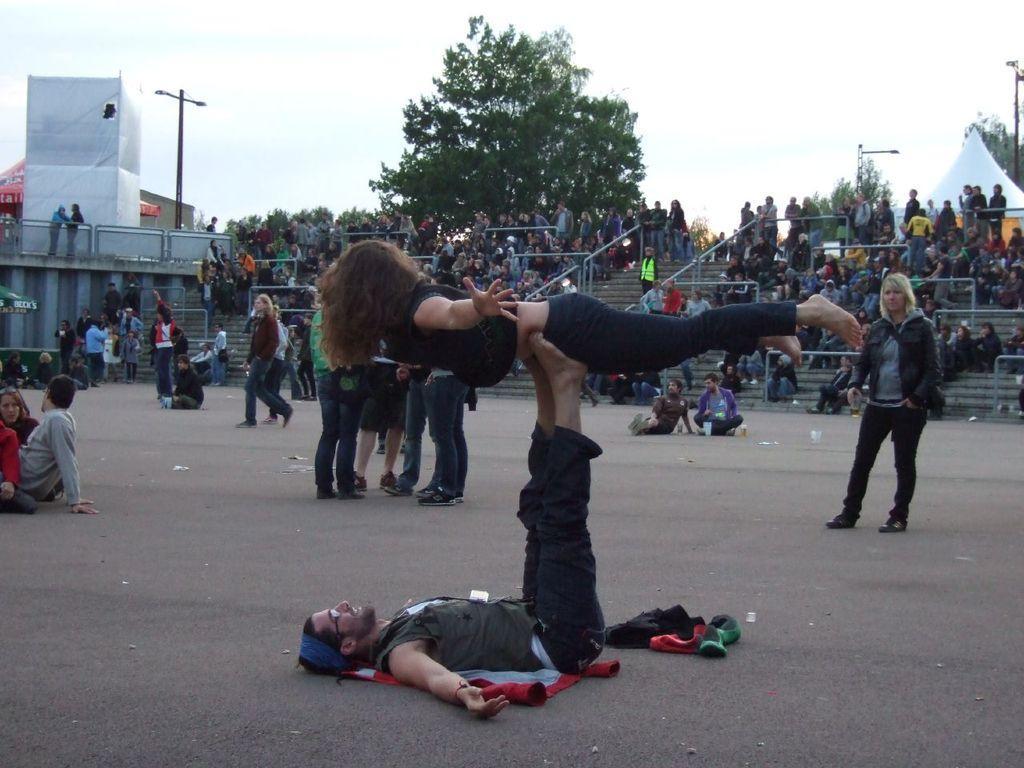How would you summarize this image in a sentence or two? This picture describes about group of people, few people are seated and few are standing, in the background we can see few metal rods, trees, tents and houses, and also we can see poles. 